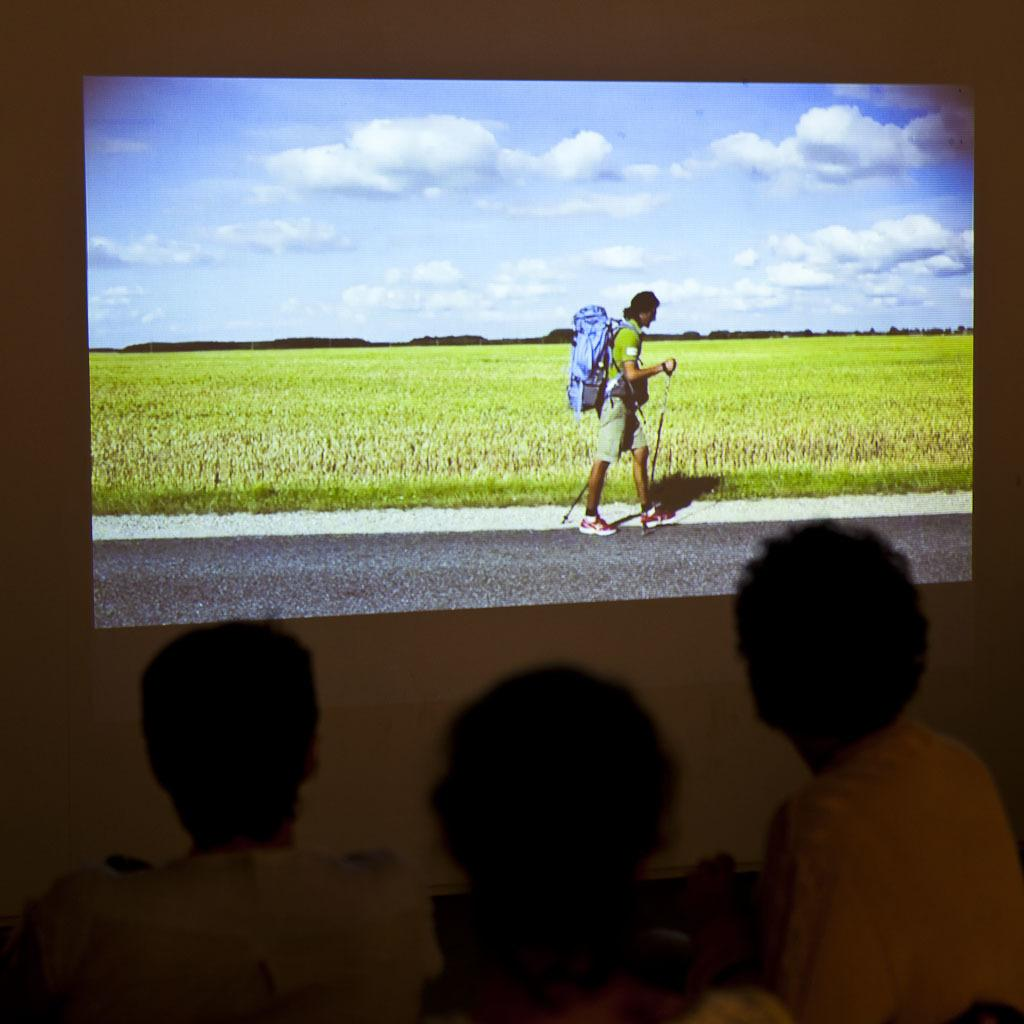How many people are in the image? There is a group of people in the image. What are the people doing in the image? The people are watching a screen. What can be seen in the background of the image? There is a cloudy sky visible in the background of the image. What type of doll is the dog holding in the image? There is no doll or dog present in the image. What is the answer to the question that the people are discussing in the image? The image does not provide any information about a question being discussed or an answer being given. 